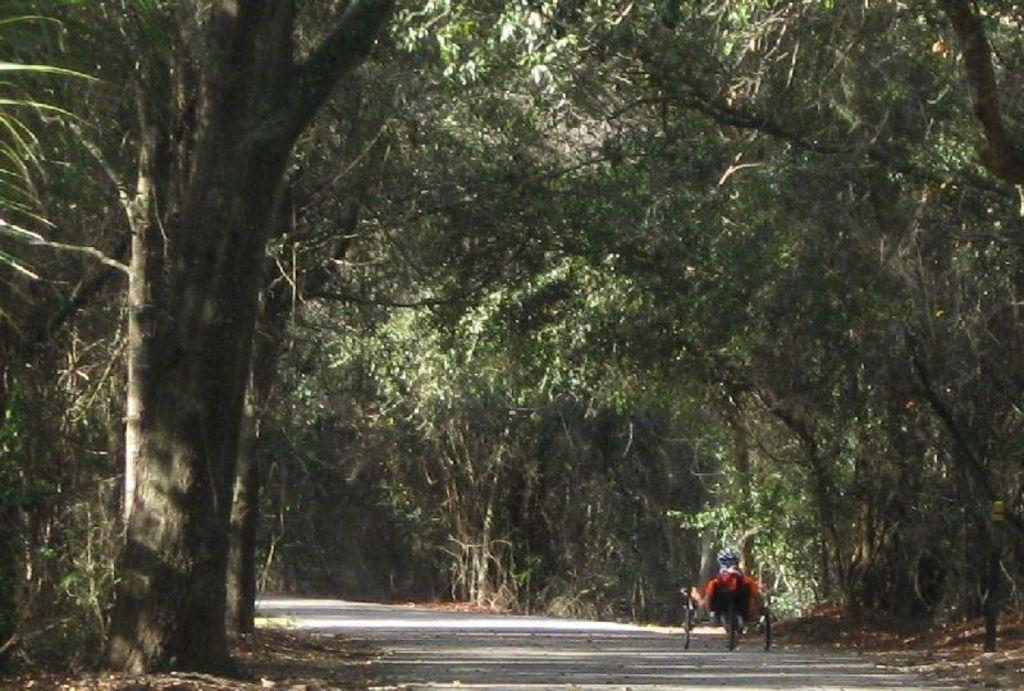What type of vegetation can be seen in the image? There are trees in the image. What is located on the road in the image? There is an object on the road in the image. What type of reaction can be seen from the trees in the image? There is no reaction from the trees in the image, as trees do not have the ability to react. How many cherries are visible on the object on the road in the image? There is no mention of cherries in the image, so it is not possible to determine how many cherries are visible. 